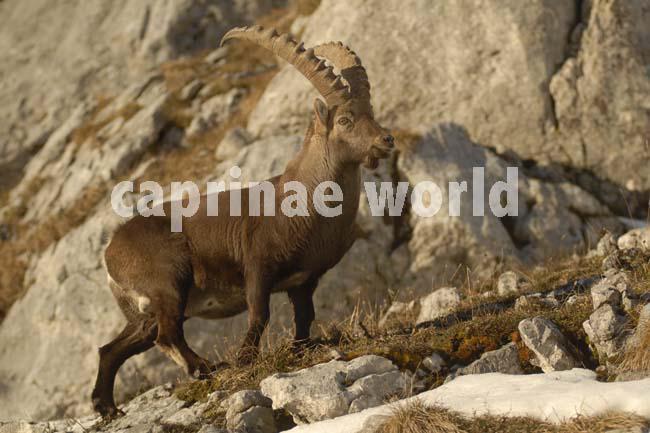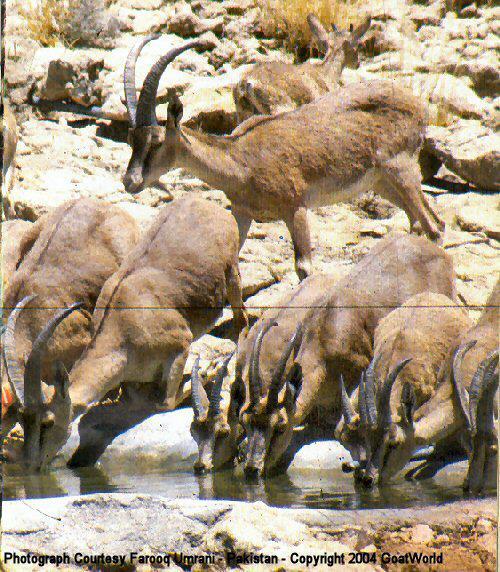The first image is the image on the left, the second image is the image on the right. Evaluate the accuracy of this statement regarding the images: "Two cloven animals are nudging each other with their heads.". Is it true? Answer yes or no. No. The first image is the image on the left, the second image is the image on the right. Considering the images on both sides, is "The image to the left contains more than one goat." valid? Answer yes or no. No. 